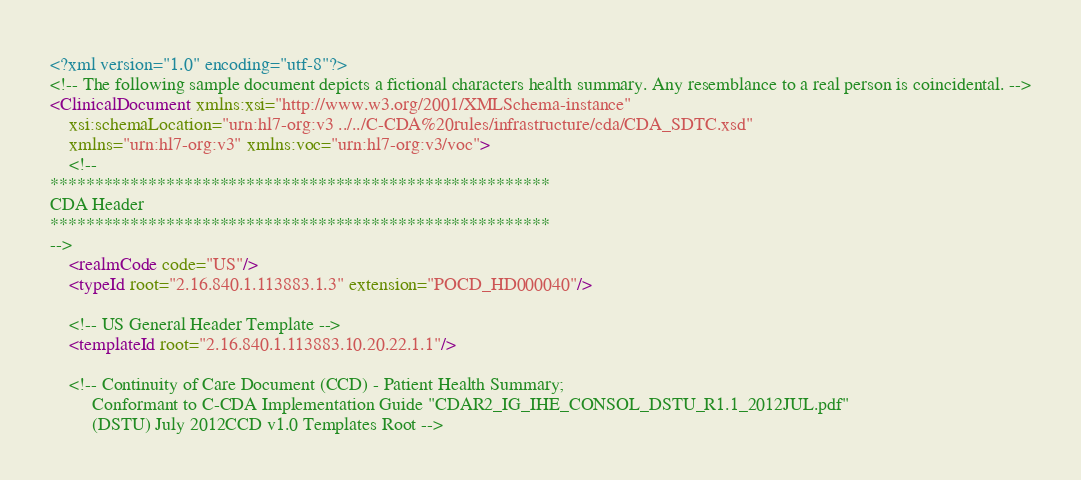<code> <loc_0><loc_0><loc_500><loc_500><_XML_><?xml version="1.0" encoding="utf-8"?>
<!-- The following sample document depicts a fictional characters health summary. Any resemblance to a real person is coincidental. -->
<ClinicalDocument xmlns:xsi="http://www.w3.org/2001/XMLSchema-instance"
	xsi:schemaLocation="urn:hl7-org:v3 ../../C-CDA%20rules/infrastructure/cda/CDA_SDTC.xsd"
	xmlns="urn:hl7-org:v3" xmlns:voc="urn:hl7-org:v3/voc">
	<!-- 
********************************************************
CDA Header
********************************************************
-->
   	<realmCode code="US"/>
	<typeId root="2.16.840.1.113883.1.3" extension="POCD_HD000040"/>
	
	<!-- US General Header Template -->	
	<templateId root="2.16.840.1.113883.10.20.22.1.1"/>
	
	<!-- Continuity of Care Document (CCD) - Patient Health Summary;
		 Conformant to C-CDA Implementation Guide "CDAR2_IG_IHE_CONSOL_DSTU_R1.1_2012JUL.pdf"
		 (DSTU) July 2012CCD v1.0 Templates Root --></code> 